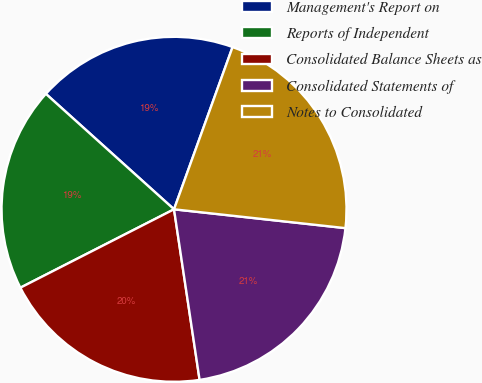<chart> <loc_0><loc_0><loc_500><loc_500><pie_chart><fcel>Management's Report on<fcel>Reports of Independent<fcel>Consolidated Balance Sheets as<fcel>Consolidated Statements of<fcel>Notes to Consolidated<nl><fcel>18.84%<fcel>19.18%<fcel>19.86%<fcel>20.89%<fcel>21.23%<nl></chart> 